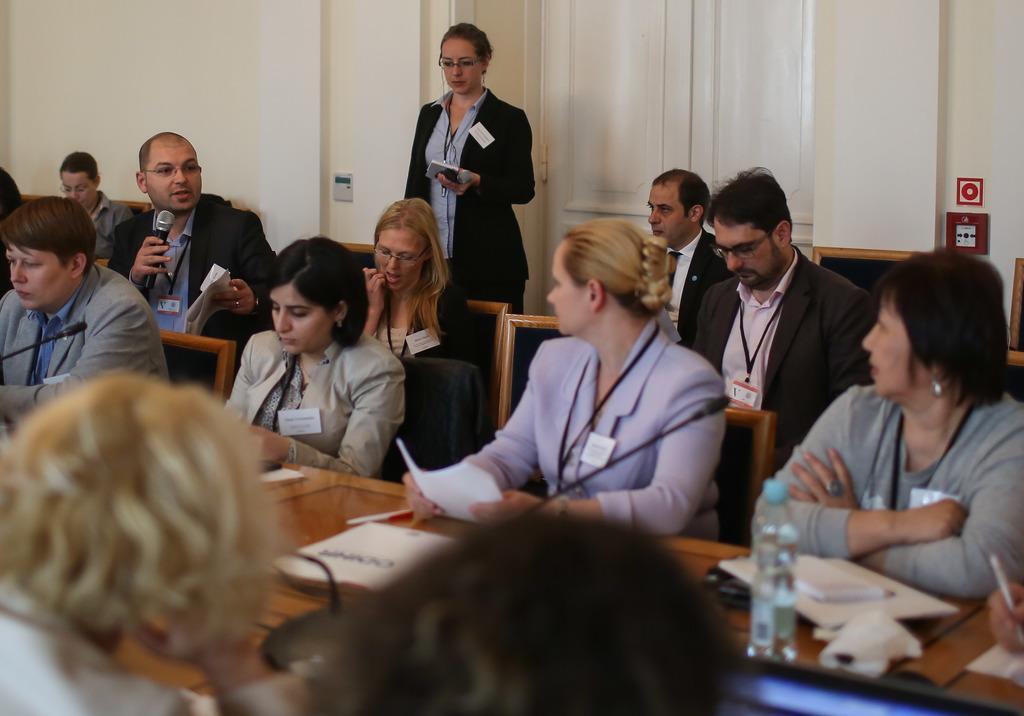In one or two sentences, can you explain what this image depicts? In the picture we can see some people are sitting on the chairs, they are in blazers and tags with Id cards and behind them, we can see a woman standing she is also wearing a blazer and holding a mobile phone and in front of the people we can see a desk with some papers and water bottle on it, and in the background we can see a wall. 